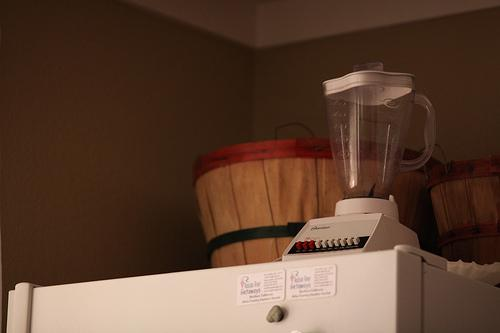Question: what kind of room is this?
Choices:
A. Living room.
B. Dining room.
C. Kitchen.
D. Bedroom.
Answer with the letter. Answer: C Question: what is the object on top of the refrigerator with the white top?
Choices:
A. Picture frame.
B. Blender.
C. Container of food.
D. Water bottle.
Answer with the letter. Answer: B Question: what is the object behind the blender?
Choices:
A. Vase.
B. Bowl.
C. Basket.
D. Cup.
Answer with the letter. Answer: C Question: how many red button are on the blender?
Choices:
A. Two.
B. Three.
C. One.
D. Four.
Answer with the letter. Answer: B Question: how many white buttons are on the blender?
Choices:
A. Seven.
B. Two.
C. One.
D. Six.
Answer with the letter. Answer: A Question: how many cards on on the front of the refrigerator?
Choices:
A. Three.
B. Five.
C. One.
D. Two.
Answer with the letter. Answer: D Question: where is this scene taking place?
Choices:
A. On top of a refrigerator.
B. Under the counter.
C. On the table.
D. In the bed.
Answer with the letter. Answer: A 